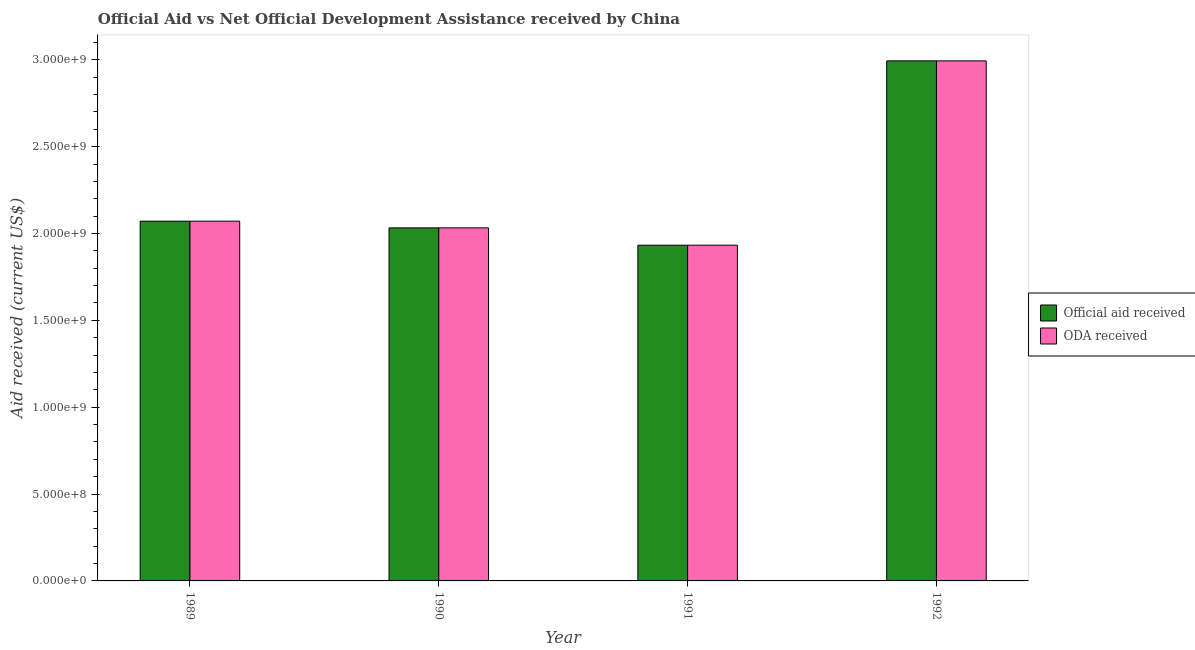Are the number of bars per tick equal to the number of legend labels?
Your answer should be compact. Yes. How many bars are there on the 2nd tick from the left?
Offer a terse response. 2. How many bars are there on the 2nd tick from the right?
Provide a short and direct response. 2. What is the official aid received in 1992?
Your answer should be very brief. 2.99e+09. Across all years, what is the maximum oda received?
Provide a succinct answer. 2.99e+09. Across all years, what is the minimum oda received?
Give a very brief answer. 1.93e+09. In which year was the oda received maximum?
Your answer should be compact. 1992. What is the total official aid received in the graph?
Your response must be concise. 9.03e+09. What is the difference between the official aid received in 1990 and that in 1992?
Keep it short and to the point. -9.61e+08. What is the difference between the official aid received in 1990 and the oda received in 1992?
Your answer should be very brief. -9.61e+08. What is the average oda received per year?
Keep it short and to the point. 2.26e+09. What is the ratio of the official aid received in 1990 to that in 1991?
Provide a succinct answer. 1.05. Is the oda received in 1989 less than that in 1992?
Make the answer very short. Yes. What is the difference between the highest and the second highest oda received?
Make the answer very short. 9.23e+08. What is the difference between the highest and the lowest oda received?
Your answer should be very brief. 1.06e+09. In how many years, is the official aid received greater than the average official aid received taken over all years?
Make the answer very short. 1. Is the sum of the oda received in 1989 and 1990 greater than the maximum official aid received across all years?
Provide a succinct answer. Yes. What does the 2nd bar from the left in 1992 represents?
Provide a short and direct response. ODA received. What does the 2nd bar from the right in 1991 represents?
Give a very brief answer. Official aid received. How many bars are there?
Offer a terse response. 8. How many years are there in the graph?
Your answer should be compact. 4. What is the difference between two consecutive major ticks on the Y-axis?
Provide a succinct answer. 5.00e+08. Are the values on the major ticks of Y-axis written in scientific E-notation?
Offer a terse response. Yes. Does the graph contain any zero values?
Make the answer very short. No. Does the graph contain grids?
Keep it short and to the point. No. Where does the legend appear in the graph?
Offer a terse response. Center right. How many legend labels are there?
Give a very brief answer. 2. What is the title of the graph?
Your answer should be compact. Official Aid vs Net Official Development Assistance received by China . What is the label or title of the Y-axis?
Keep it short and to the point. Aid received (current US$). What is the Aid received (current US$) in Official aid received in 1989?
Offer a very short reply. 2.07e+09. What is the Aid received (current US$) in ODA received in 1989?
Your answer should be very brief. 2.07e+09. What is the Aid received (current US$) of Official aid received in 1990?
Provide a succinct answer. 2.03e+09. What is the Aid received (current US$) in ODA received in 1990?
Give a very brief answer. 2.03e+09. What is the Aid received (current US$) of Official aid received in 1991?
Provide a short and direct response. 1.93e+09. What is the Aid received (current US$) of ODA received in 1991?
Offer a very short reply. 1.93e+09. What is the Aid received (current US$) of Official aid received in 1992?
Provide a succinct answer. 2.99e+09. What is the Aid received (current US$) in ODA received in 1992?
Your response must be concise. 2.99e+09. Across all years, what is the maximum Aid received (current US$) in Official aid received?
Your response must be concise. 2.99e+09. Across all years, what is the maximum Aid received (current US$) in ODA received?
Make the answer very short. 2.99e+09. Across all years, what is the minimum Aid received (current US$) in Official aid received?
Make the answer very short. 1.93e+09. Across all years, what is the minimum Aid received (current US$) in ODA received?
Your answer should be very brief. 1.93e+09. What is the total Aid received (current US$) of Official aid received in the graph?
Ensure brevity in your answer.  9.03e+09. What is the total Aid received (current US$) in ODA received in the graph?
Keep it short and to the point. 9.03e+09. What is the difference between the Aid received (current US$) of Official aid received in 1989 and that in 1990?
Provide a succinct answer. 3.85e+07. What is the difference between the Aid received (current US$) in ODA received in 1989 and that in 1990?
Offer a very short reply. 3.85e+07. What is the difference between the Aid received (current US$) of Official aid received in 1989 and that in 1991?
Your answer should be compact. 1.38e+08. What is the difference between the Aid received (current US$) of ODA received in 1989 and that in 1991?
Give a very brief answer. 1.38e+08. What is the difference between the Aid received (current US$) in Official aid received in 1989 and that in 1992?
Give a very brief answer. -9.23e+08. What is the difference between the Aid received (current US$) of ODA received in 1989 and that in 1992?
Provide a succinct answer. -9.23e+08. What is the difference between the Aid received (current US$) of Official aid received in 1990 and that in 1991?
Ensure brevity in your answer.  9.98e+07. What is the difference between the Aid received (current US$) in ODA received in 1990 and that in 1991?
Offer a terse response. 9.98e+07. What is the difference between the Aid received (current US$) in Official aid received in 1990 and that in 1992?
Offer a very short reply. -9.61e+08. What is the difference between the Aid received (current US$) of ODA received in 1990 and that in 1992?
Provide a succinct answer. -9.61e+08. What is the difference between the Aid received (current US$) of Official aid received in 1991 and that in 1992?
Provide a short and direct response. -1.06e+09. What is the difference between the Aid received (current US$) of ODA received in 1991 and that in 1992?
Provide a short and direct response. -1.06e+09. What is the difference between the Aid received (current US$) in Official aid received in 1989 and the Aid received (current US$) in ODA received in 1990?
Provide a short and direct response. 3.85e+07. What is the difference between the Aid received (current US$) in Official aid received in 1989 and the Aid received (current US$) in ODA received in 1991?
Ensure brevity in your answer.  1.38e+08. What is the difference between the Aid received (current US$) in Official aid received in 1989 and the Aid received (current US$) in ODA received in 1992?
Your answer should be compact. -9.23e+08. What is the difference between the Aid received (current US$) of Official aid received in 1990 and the Aid received (current US$) of ODA received in 1991?
Offer a terse response. 9.98e+07. What is the difference between the Aid received (current US$) of Official aid received in 1990 and the Aid received (current US$) of ODA received in 1992?
Your answer should be compact. -9.61e+08. What is the difference between the Aid received (current US$) of Official aid received in 1991 and the Aid received (current US$) of ODA received in 1992?
Your answer should be very brief. -1.06e+09. What is the average Aid received (current US$) of Official aid received per year?
Your response must be concise. 2.26e+09. What is the average Aid received (current US$) in ODA received per year?
Provide a short and direct response. 2.26e+09. In the year 1989, what is the difference between the Aid received (current US$) in Official aid received and Aid received (current US$) in ODA received?
Offer a very short reply. 0. In the year 1992, what is the difference between the Aid received (current US$) in Official aid received and Aid received (current US$) in ODA received?
Make the answer very short. 0. What is the ratio of the Aid received (current US$) in Official aid received in 1989 to that in 1990?
Your answer should be compact. 1.02. What is the ratio of the Aid received (current US$) in ODA received in 1989 to that in 1990?
Make the answer very short. 1.02. What is the ratio of the Aid received (current US$) in Official aid received in 1989 to that in 1991?
Give a very brief answer. 1.07. What is the ratio of the Aid received (current US$) in ODA received in 1989 to that in 1991?
Give a very brief answer. 1.07. What is the ratio of the Aid received (current US$) in Official aid received in 1989 to that in 1992?
Ensure brevity in your answer.  0.69. What is the ratio of the Aid received (current US$) of ODA received in 1989 to that in 1992?
Offer a terse response. 0.69. What is the ratio of the Aid received (current US$) in Official aid received in 1990 to that in 1991?
Offer a very short reply. 1.05. What is the ratio of the Aid received (current US$) in ODA received in 1990 to that in 1991?
Ensure brevity in your answer.  1.05. What is the ratio of the Aid received (current US$) in Official aid received in 1990 to that in 1992?
Ensure brevity in your answer.  0.68. What is the ratio of the Aid received (current US$) of ODA received in 1990 to that in 1992?
Provide a short and direct response. 0.68. What is the ratio of the Aid received (current US$) in Official aid received in 1991 to that in 1992?
Offer a very short reply. 0.65. What is the ratio of the Aid received (current US$) of ODA received in 1991 to that in 1992?
Ensure brevity in your answer.  0.65. What is the difference between the highest and the second highest Aid received (current US$) in Official aid received?
Make the answer very short. 9.23e+08. What is the difference between the highest and the second highest Aid received (current US$) of ODA received?
Provide a succinct answer. 9.23e+08. What is the difference between the highest and the lowest Aid received (current US$) in Official aid received?
Your answer should be very brief. 1.06e+09. What is the difference between the highest and the lowest Aid received (current US$) in ODA received?
Your answer should be very brief. 1.06e+09. 